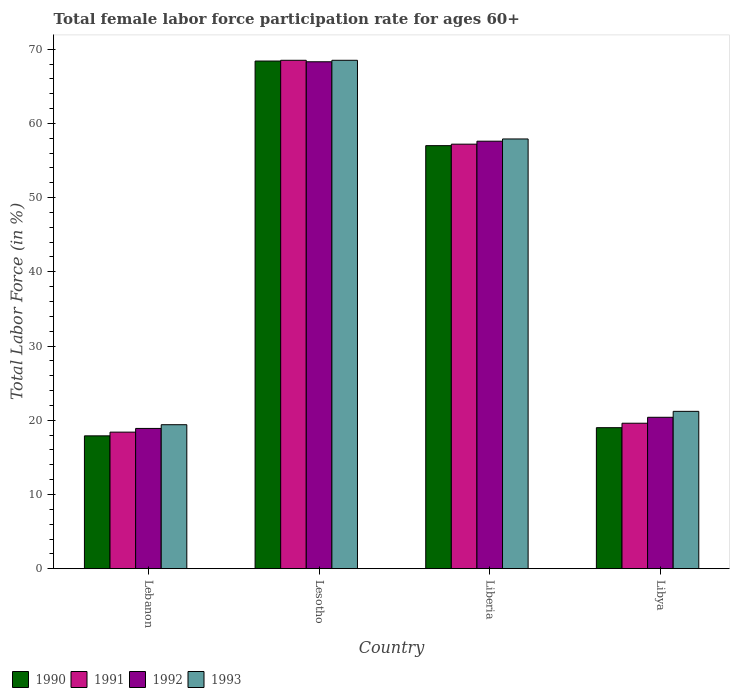How many different coloured bars are there?
Your answer should be compact. 4. How many groups of bars are there?
Your response must be concise. 4. Are the number of bars per tick equal to the number of legend labels?
Your answer should be very brief. Yes. Are the number of bars on each tick of the X-axis equal?
Provide a succinct answer. Yes. How many bars are there on the 2nd tick from the left?
Make the answer very short. 4. How many bars are there on the 3rd tick from the right?
Offer a terse response. 4. What is the label of the 4th group of bars from the left?
Ensure brevity in your answer.  Libya. In how many cases, is the number of bars for a given country not equal to the number of legend labels?
Your answer should be very brief. 0. What is the female labor force participation rate in 1992 in Lebanon?
Keep it short and to the point. 18.9. Across all countries, what is the maximum female labor force participation rate in 1990?
Provide a succinct answer. 68.4. Across all countries, what is the minimum female labor force participation rate in 1993?
Your answer should be compact. 19.4. In which country was the female labor force participation rate in 1993 maximum?
Your answer should be compact. Lesotho. In which country was the female labor force participation rate in 1990 minimum?
Your answer should be very brief. Lebanon. What is the total female labor force participation rate in 1992 in the graph?
Provide a succinct answer. 165.2. What is the difference between the female labor force participation rate in 1992 in Lebanon and that in Liberia?
Offer a terse response. -38.7. What is the difference between the female labor force participation rate in 1990 in Libya and the female labor force participation rate in 1993 in Lebanon?
Your answer should be compact. -0.4. What is the average female labor force participation rate in 1992 per country?
Offer a very short reply. 41.3. What is the difference between the female labor force participation rate of/in 1993 and female labor force participation rate of/in 1990 in Libya?
Your answer should be very brief. 2.2. What is the ratio of the female labor force participation rate in 1993 in Lesotho to that in Libya?
Offer a terse response. 3.23. Is the difference between the female labor force participation rate in 1993 in Liberia and Libya greater than the difference between the female labor force participation rate in 1990 in Liberia and Libya?
Make the answer very short. No. What is the difference between the highest and the second highest female labor force participation rate in 1991?
Keep it short and to the point. 37.6. What is the difference between the highest and the lowest female labor force participation rate in 1990?
Your answer should be very brief. 50.5. In how many countries, is the female labor force participation rate in 1991 greater than the average female labor force participation rate in 1991 taken over all countries?
Give a very brief answer. 2. Is the sum of the female labor force participation rate in 1992 in Liberia and Libya greater than the maximum female labor force participation rate in 1993 across all countries?
Give a very brief answer. Yes. Is it the case that in every country, the sum of the female labor force participation rate in 1990 and female labor force participation rate in 1993 is greater than the sum of female labor force participation rate in 1991 and female labor force participation rate in 1992?
Provide a short and direct response. No. What does the 4th bar from the right in Lesotho represents?
Your response must be concise. 1990. How many bars are there?
Offer a very short reply. 16. How many legend labels are there?
Your answer should be compact. 4. What is the title of the graph?
Your answer should be compact. Total female labor force participation rate for ages 60+. What is the label or title of the Y-axis?
Provide a short and direct response. Total Labor Force (in %). What is the Total Labor Force (in %) of 1990 in Lebanon?
Your answer should be compact. 17.9. What is the Total Labor Force (in %) in 1991 in Lebanon?
Provide a short and direct response. 18.4. What is the Total Labor Force (in %) in 1992 in Lebanon?
Your answer should be very brief. 18.9. What is the Total Labor Force (in %) of 1993 in Lebanon?
Give a very brief answer. 19.4. What is the Total Labor Force (in %) in 1990 in Lesotho?
Keep it short and to the point. 68.4. What is the Total Labor Force (in %) of 1991 in Lesotho?
Ensure brevity in your answer.  68.5. What is the Total Labor Force (in %) in 1992 in Lesotho?
Give a very brief answer. 68.3. What is the Total Labor Force (in %) of 1993 in Lesotho?
Your response must be concise. 68.5. What is the Total Labor Force (in %) of 1991 in Liberia?
Ensure brevity in your answer.  57.2. What is the Total Labor Force (in %) in 1992 in Liberia?
Your answer should be compact. 57.6. What is the Total Labor Force (in %) of 1993 in Liberia?
Make the answer very short. 57.9. What is the Total Labor Force (in %) in 1990 in Libya?
Give a very brief answer. 19. What is the Total Labor Force (in %) in 1991 in Libya?
Offer a very short reply. 19.6. What is the Total Labor Force (in %) in 1992 in Libya?
Provide a succinct answer. 20.4. What is the Total Labor Force (in %) of 1993 in Libya?
Keep it short and to the point. 21.2. Across all countries, what is the maximum Total Labor Force (in %) in 1990?
Make the answer very short. 68.4. Across all countries, what is the maximum Total Labor Force (in %) of 1991?
Your answer should be very brief. 68.5. Across all countries, what is the maximum Total Labor Force (in %) in 1992?
Offer a very short reply. 68.3. Across all countries, what is the maximum Total Labor Force (in %) of 1993?
Make the answer very short. 68.5. Across all countries, what is the minimum Total Labor Force (in %) in 1990?
Offer a terse response. 17.9. Across all countries, what is the minimum Total Labor Force (in %) in 1991?
Ensure brevity in your answer.  18.4. Across all countries, what is the minimum Total Labor Force (in %) of 1992?
Give a very brief answer. 18.9. Across all countries, what is the minimum Total Labor Force (in %) of 1993?
Offer a very short reply. 19.4. What is the total Total Labor Force (in %) of 1990 in the graph?
Offer a very short reply. 162.3. What is the total Total Labor Force (in %) in 1991 in the graph?
Ensure brevity in your answer.  163.7. What is the total Total Labor Force (in %) in 1992 in the graph?
Your answer should be very brief. 165.2. What is the total Total Labor Force (in %) in 1993 in the graph?
Provide a short and direct response. 167. What is the difference between the Total Labor Force (in %) of 1990 in Lebanon and that in Lesotho?
Offer a terse response. -50.5. What is the difference between the Total Labor Force (in %) in 1991 in Lebanon and that in Lesotho?
Your answer should be very brief. -50.1. What is the difference between the Total Labor Force (in %) in 1992 in Lebanon and that in Lesotho?
Provide a short and direct response. -49.4. What is the difference between the Total Labor Force (in %) of 1993 in Lebanon and that in Lesotho?
Provide a short and direct response. -49.1. What is the difference between the Total Labor Force (in %) of 1990 in Lebanon and that in Liberia?
Your answer should be compact. -39.1. What is the difference between the Total Labor Force (in %) in 1991 in Lebanon and that in Liberia?
Provide a short and direct response. -38.8. What is the difference between the Total Labor Force (in %) in 1992 in Lebanon and that in Liberia?
Offer a very short reply. -38.7. What is the difference between the Total Labor Force (in %) of 1993 in Lebanon and that in Liberia?
Keep it short and to the point. -38.5. What is the difference between the Total Labor Force (in %) of 1990 in Lebanon and that in Libya?
Your response must be concise. -1.1. What is the difference between the Total Labor Force (in %) of 1993 in Lebanon and that in Libya?
Your answer should be very brief. -1.8. What is the difference between the Total Labor Force (in %) in 1992 in Lesotho and that in Liberia?
Your answer should be compact. 10.7. What is the difference between the Total Labor Force (in %) in 1990 in Lesotho and that in Libya?
Provide a succinct answer. 49.4. What is the difference between the Total Labor Force (in %) of 1991 in Lesotho and that in Libya?
Ensure brevity in your answer.  48.9. What is the difference between the Total Labor Force (in %) in 1992 in Lesotho and that in Libya?
Provide a short and direct response. 47.9. What is the difference between the Total Labor Force (in %) in 1993 in Lesotho and that in Libya?
Make the answer very short. 47.3. What is the difference between the Total Labor Force (in %) of 1990 in Liberia and that in Libya?
Offer a very short reply. 38. What is the difference between the Total Labor Force (in %) in 1991 in Liberia and that in Libya?
Your answer should be compact. 37.6. What is the difference between the Total Labor Force (in %) of 1992 in Liberia and that in Libya?
Give a very brief answer. 37.2. What is the difference between the Total Labor Force (in %) in 1993 in Liberia and that in Libya?
Offer a very short reply. 36.7. What is the difference between the Total Labor Force (in %) of 1990 in Lebanon and the Total Labor Force (in %) of 1991 in Lesotho?
Make the answer very short. -50.6. What is the difference between the Total Labor Force (in %) of 1990 in Lebanon and the Total Labor Force (in %) of 1992 in Lesotho?
Make the answer very short. -50.4. What is the difference between the Total Labor Force (in %) in 1990 in Lebanon and the Total Labor Force (in %) in 1993 in Lesotho?
Keep it short and to the point. -50.6. What is the difference between the Total Labor Force (in %) of 1991 in Lebanon and the Total Labor Force (in %) of 1992 in Lesotho?
Offer a terse response. -49.9. What is the difference between the Total Labor Force (in %) in 1991 in Lebanon and the Total Labor Force (in %) in 1993 in Lesotho?
Ensure brevity in your answer.  -50.1. What is the difference between the Total Labor Force (in %) of 1992 in Lebanon and the Total Labor Force (in %) of 1993 in Lesotho?
Your response must be concise. -49.6. What is the difference between the Total Labor Force (in %) of 1990 in Lebanon and the Total Labor Force (in %) of 1991 in Liberia?
Offer a terse response. -39.3. What is the difference between the Total Labor Force (in %) of 1990 in Lebanon and the Total Labor Force (in %) of 1992 in Liberia?
Offer a very short reply. -39.7. What is the difference between the Total Labor Force (in %) in 1990 in Lebanon and the Total Labor Force (in %) in 1993 in Liberia?
Keep it short and to the point. -40. What is the difference between the Total Labor Force (in %) of 1991 in Lebanon and the Total Labor Force (in %) of 1992 in Liberia?
Offer a very short reply. -39.2. What is the difference between the Total Labor Force (in %) in 1991 in Lebanon and the Total Labor Force (in %) in 1993 in Liberia?
Your response must be concise. -39.5. What is the difference between the Total Labor Force (in %) of 1992 in Lebanon and the Total Labor Force (in %) of 1993 in Liberia?
Ensure brevity in your answer.  -39. What is the difference between the Total Labor Force (in %) in 1990 in Lebanon and the Total Labor Force (in %) in 1991 in Libya?
Offer a terse response. -1.7. What is the difference between the Total Labor Force (in %) of 1990 in Lebanon and the Total Labor Force (in %) of 1993 in Libya?
Offer a terse response. -3.3. What is the difference between the Total Labor Force (in %) of 1991 in Lebanon and the Total Labor Force (in %) of 1992 in Libya?
Provide a succinct answer. -2. What is the difference between the Total Labor Force (in %) in 1990 in Lesotho and the Total Labor Force (in %) in 1991 in Liberia?
Your response must be concise. 11.2. What is the difference between the Total Labor Force (in %) of 1990 in Lesotho and the Total Labor Force (in %) of 1993 in Liberia?
Offer a very short reply. 10.5. What is the difference between the Total Labor Force (in %) in 1991 in Lesotho and the Total Labor Force (in %) in 1993 in Liberia?
Your answer should be compact. 10.6. What is the difference between the Total Labor Force (in %) in 1990 in Lesotho and the Total Labor Force (in %) in 1991 in Libya?
Make the answer very short. 48.8. What is the difference between the Total Labor Force (in %) of 1990 in Lesotho and the Total Labor Force (in %) of 1993 in Libya?
Make the answer very short. 47.2. What is the difference between the Total Labor Force (in %) of 1991 in Lesotho and the Total Labor Force (in %) of 1992 in Libya?
Offer a very short reply. 48.1. What is the difference between the Total Labor Force (in %) in 1991 in Lesotho and the Total Labor Force (in %) in 1993 in Libya?
Provide a short and direct response. 47.3. What is the difference between the Total Labor Force (in %) in 1992 in Lesotho and the Total Labor Force (in %) in 1993 in Libya?
Offer a very short reply. 47.1. What is the difference between the Total Labor Force (in %) of 1990 in Liberia and the Total Labor Force (in %) of 1991 in Libya?
Make the answer very short. 37.4. What is the difference between the Total Labor Force (in %) of 1990 in Liberia and the Total Labor Force (in %) of 1992 in Libya?
Your response must be concise. 36.6. What is the difference between the Total Labor Force (in %) in 1990 in Liberia and the Total Labor Force (in %) in 1993 in Libya?
Make the answer very short. 35.8. What is the difference between the Total Labor Force (in %) of 1991 in Liberia and the Total Labor Force (in %) of 1992 in Libya?
Give a very brief answer. 36.8. What is the difference between the Total Labor Force (in %) in 1991 in Liberia and the Total Labor Force (in %) in 1993 in Libya?
Offer a very short reply. 36. What is the difference between the Total Labor Force (in %) of 1992 in Liberia and the Total Labor Force (in %) of 1993 in Libya?
Offer a very short reply. 36.4. What is the average Total Labor Force (in %) of 1990 per country?
Keep it short and to the point. 40.58. What is the average Total Labor Force (in %) of 1991 per country?
Your answer should be compact. 40.92. What is the average Total Labor Force (in %) in 1992 per country?
Give a very brief answer. 41.3. What is the average Total Labor Force (in %) in 1993 per country?
Keep it short and to the point. 41.75. What is the difference between the Total Labor Force (in %) in 1990 and Total Labor Force (in %) in 1993 in Lebanon?
Provide a short and direct response. -1.5. What is the difference between the Total Labor Force (in %) of 1991 and Total Labor Force (in %) of 1992 in Lebanon?
Your answer should be very brief. -0.5. What is the difference between the Total Labor Force (in %) of 1990 and Total Labor Force (in %) of 1991 in Lesotho?
Your answer should be compact. -0.1. What is the difference between the Total Labor Force (in %) in 1991 and Total Labor Force (in %) in 1992 in Lesotho?
Your answer should be compact. 0.2. What is the difference between the Total Labor Force (in %) in 1991 and Total Labor Force (in %) in 1993 in Lesotho?
Keep it short and to the point. 0. What is the difference between the Total Labor Force (in %) of 1990 and Total Labor Force (in %) of 1991 in Liberia?
Give a very brief answer. -0.2. What is the difference between the Total Labor Force (in %) in 1990 and Total Labor Force (in %) in 1992 in Liberia?
Offer a very short reply. -0.6. What is the difference between the Total Labor Force (in %) of 1991 and Total Labor Force (in %) of 1992 in Liberia?
Ensure brevity in your answer.  -0.4. What is the difference between the Total Labor Force (in %) in 1991 and Total Labor Force (in %) in 1993 in Liberia?
Provide a succinct answer. -0.7. What is the difference between the Total Labor Force (in %) of 1992 and Total Labor Force (in %) of 1993 in Liberia?
Give a very brief answer. -0.3. What is the difference between the Total Labor Force (in %) of 1990 and Total Labor Force (in %) of 1993 in Libya?
Make the answer very short. -2.2. What is the difference between the Total Labor Force (in %) in 1991 and Total Labor Force (in %) in 1992 in Libya?
Your answer should be compact. -0.8. What is the ratio of the Total Labor Force (in %) in 1990 in Lebanon to that in Lesotho?
Make the answer very short. 0.26. What is the ratio of the Total Labor Force (in %) in 1991 in Lebanon to that in Lesotho?
Offer a terse response. 0.27. What is the ratio of the Total Labor Force (in %) in 1992 in Lebanon to that in Lesotho?
Make the answer very short. 0.28. What is the ratio of the Total Labor Force (in %) in 1993 in Lebanon to that in Lesotho?
Make the answer very short. 0.28. What is the ratio of the Total Labor Force (in %) of 1990 in Lebanon to that in Liberia?
Your answer should be very brief. 0.31. What is the ratio of the Total Labor Force (in %) of 1991 in Lebanon to that in Liberia?
Provide a short and direct response. 0.32. What is the ratio of the Total Labor Force (in %) of 1992 in Lebanon to that in Liberia?
Offer a terse response. 0.33. What is the ratio of the Total Labor Force (in %) in 1993 in Lebanon to that in Liberia?
Make the answer very short. 0.34. What is the ratio of the Total Labor Force (in %) of 1990 in Lebanon to that in Libya?
Keep it short and to the point. 0.94. What is the ratio of the Total Labor Force (in %) of 1991 in Lebanon to that in Libya?
Keep it short and to the point. 0.94. What is the ratio of the Total Labor Force (in %) of 1992 in Lebanon to that in Libya?
Give a very brief answer. 0.93. What is the ratio of the Total Labor Force (in %) in 1993 in Lebanon to that in Libya?
Offer a terse response. 0.92. What is the ratio of the Total Labor Force (in %) in 1991 in Lesotho to that in Liberia?
Provide a succinct answer. 1.2. What is the ratio of the Total Labor Force (in %) of 1992 in Lesotho to that in Liberia?
Your response must be concise. 1.19. What is the ratio of the Total Labor Force (in %) of 1993 in Lesotho to that in Liberia?
Your answer should be very brief. 1.18. What is the ratio of the Total Labor Force (in %) in 1991 in Lesotho to that in Libya?
Provide a short and direct response. 3.49. What is the ratio of the Total Labor Force (in %) of 1992 in Lesotho to that in Libya?
Offer a terse response. 3.35. What is the ratio of the Total Labor Force (in %) of 1993 in Lesotho to that in Libya?
Your answer should be very brief. 3.23. What is the ratio of the Total Labor Force (in %) of 1991 in Liberia to that in Libya?
Provide a succinct answer. 2.92. What is the ratio of the Total Labor Force (in %) in 1992 in Liberia to that in Libya?
Ensure brevity in your answer.  2.82. What is the ratio of the Total Labor Force (in %) of 1993 in Liberia to that in Libya?
Your response must be concise. 2.73. What is the difference between the highest and the second highest Total Labor Force (in %) in 1990?
Give a very brief answer. 11.4. What is the difference between the highest and the second highest Total Labor Force (in %) in 1991?
Give a very brief answer. 11.3. What is the difference between the highest and the lowest Total Labor Force (in %) of 1990?
Give a very brief answer. 50.5. What is the difference between the highest and the lowest Total Labor Force (in %) in 1991?
Offer a terse response. 50.1. What is the difference between the highest and the lowest Total Labor Force (in %) in 1992?
Ensure brevity in your answer.  49.4. What is the difference between the highest and the lowest Total Labor Force (in %) in 1993?
Make the answer very short. 49.1. 